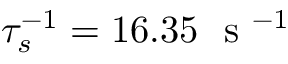<formula> <loc_0><loc_0><loc_500><loc_500>\tau _ { s } ^ { - 1 } = 1 6 . 3 5 s ^ { - 1 }</formula> 